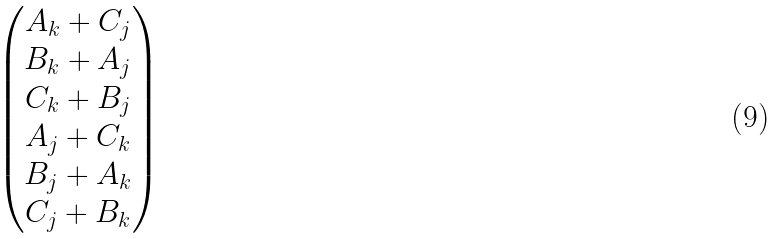Convert formula to latex. <formula><loc_0><loc_0><loc_500><loc_500>\begin{pmatrix} A _ { k } + C _ { j } \\ B _ { k } + A _ { j } \\ C _ { k } + B _ { j } \\ A _ { j } + C _ { k } \\ B _ { j } + A _ { k } \\ C _ { j } + B _ { k } \end{pmatrix}</formula> 